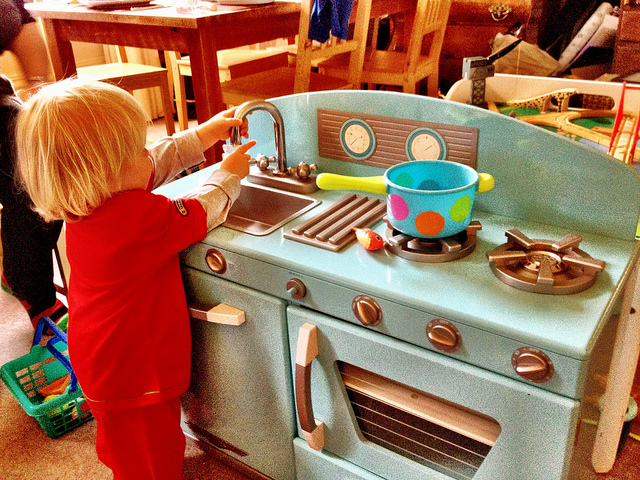What will come out of the sink?
A. gasoline
B. soda
C. water
D. nothing
Answer with the option's letter from the given choices directly. D 